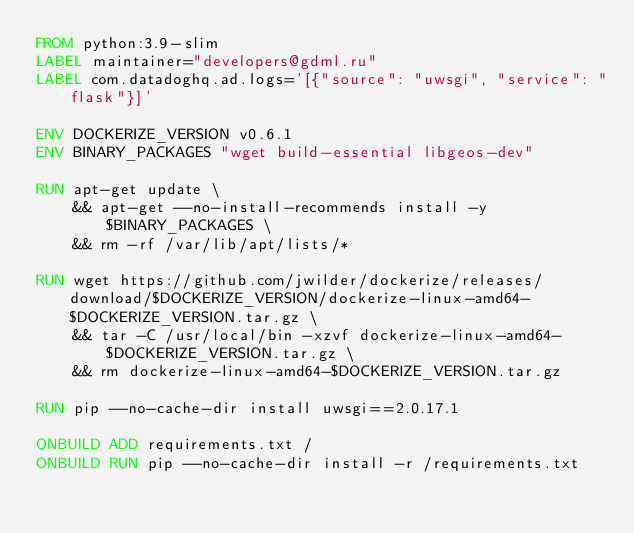<code> <loc_0><loc_0><loc_500><loc_500><_Dockerfile_>FROM python:3.9-slim
LABEL maintainer="developers@gdml.ru"
LABEL com.datadoghq.ad.logs='[{"source": "uwsgi", "service": "flask"}]'

ENV DOCKERIZE_VERSION v0.6.1
ENV BINARY_PACKAGES "wget build-essential libgeos-dev"

RUN apt-get update \
    && apt-get --no-install-recommends install -y $BINARY_PACKAGES \
    && rm -rf /var/lib/apt/lists/*

RUN wget https://github.com/jwilder/dockerize/releases/download/$DOCKERIZE_VERSION/dockerize-linux-amd64-$DOCKERIZE_VERSION.tar.gz \
    && tar -C /usr/local/bin -xzvf dockerize-linux-amd64-$DOCKERIZE_VERSION.tar.gz \
    && rm dockerize-linux-amd64-$DOCKERIZE_VERSION.tar.gz

RUN pip --no-cache-dir install uwsgi==2.0.17.1

ONBUILD ADD requirements.txt /
ONBUILD RUN pip --no-cache-dir install -r /requirements.txt
</code> 